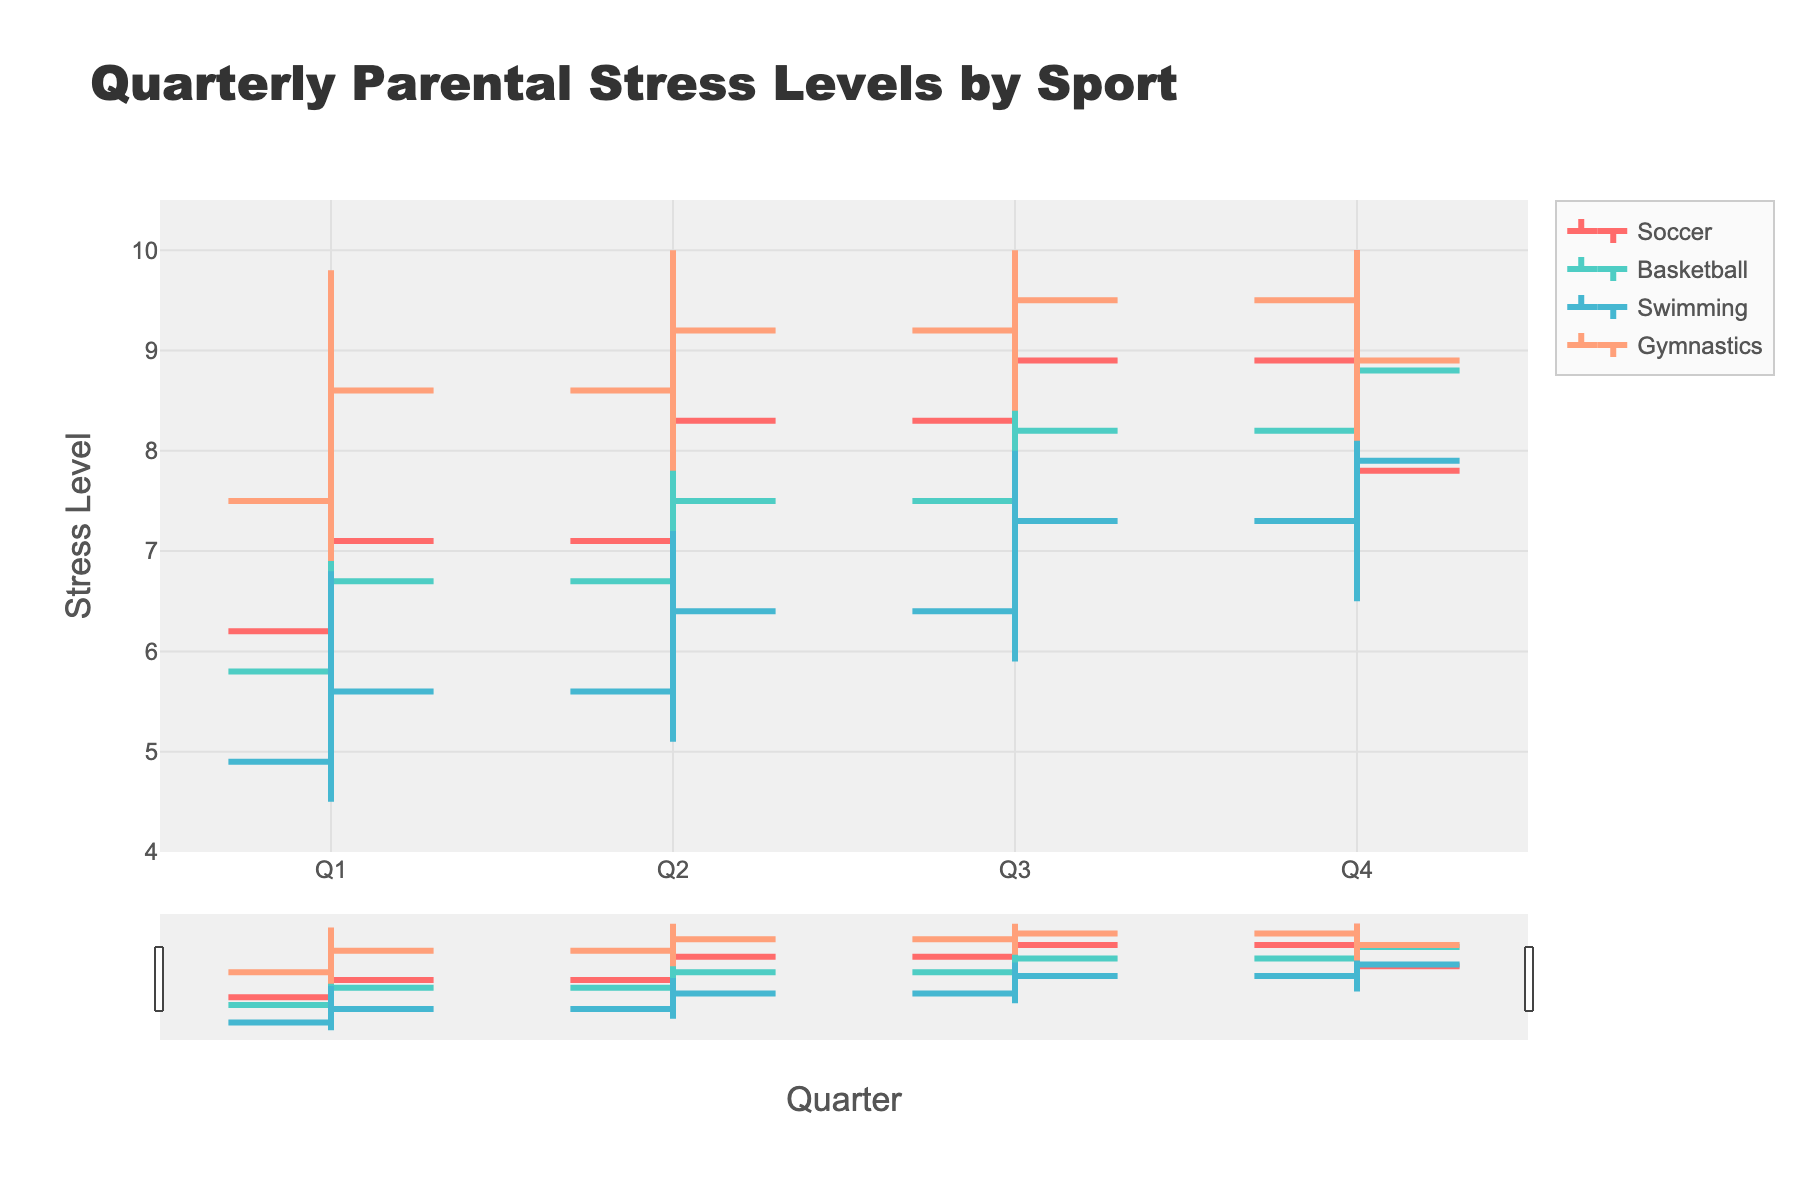Which sport has the highest stress level in Q1? The highest stress level for each sport in Q1 can be observed in the chart. Gymnastics has the highest high value of 9.8.
Answer: Gymnastics How did parental stress levels in Swimming change from Q1 to Q4? Looking at the OHLC chart for Swimming, the stress levels started at 4.9 and closed at 7.9 in Q4. Observing each quarter, it shows an upward trend.
Answer: Increased In which quarter did Basketball have the highest closing stress level? The closing stress levels for Basketball are 6.7 (Q1), 7.5 (Q2), 8.2 (Q3), and 8.8 (Q4). The highest is in Q4.
Answer: Q4 What is the variation in parental stress levels for Soccer in Q2? The variation or range can be calculated by subtracting the low value from the high value. For Soccer in Q2: 9.2 - 6.5 = 2.7.
Answer: 2.7 Compare the average stress level across all quarters between Soccer and Basketball. Which one is higher? Calculate the average for Soccer: (7.1 + 8.3 + 8.9 + 7.8) / 4 = 8.025. For Basketball: (6.7 + 7.5 + 8.2 + 8.8) / 4 = 7.8. Soccer's average is higher.
Answer: Soccer What was the trend in parental stress levels throughout the quarters for Gymnastics? Observing the OHLC chart for Gymnastics, stress levels steadily increase from Q1 to Q3 and then decrease in Q4.
Answer: Increased, then decreased Which sport had the most significant drop in closing stress levels from Q3 to Q4? Comparing the closing stress levels between Q3 and Q4 for each sport, Soccer dropped from 8.9 to 7.8, the most significant drop.
Answer: Soccer What was the lowest low value observed for Swimming? The lowest low value for Swimming across all quarters can be observed. The Q1 value of 4.5 is the lowest.
Answer: 4.5 Which quarter had the highest overall stress level across all sports? The highest overall stress level is seen in Q3 for Gymnastics and Soccer, both reaching 10.0.
Answer: Q3 How consistent were the stress levels for Gymnastics across the quarters? Observing the OHLC chart, Gymnastics shows less variation, consistently high levels with slight fluctuations.
Answer: Consistent and high 